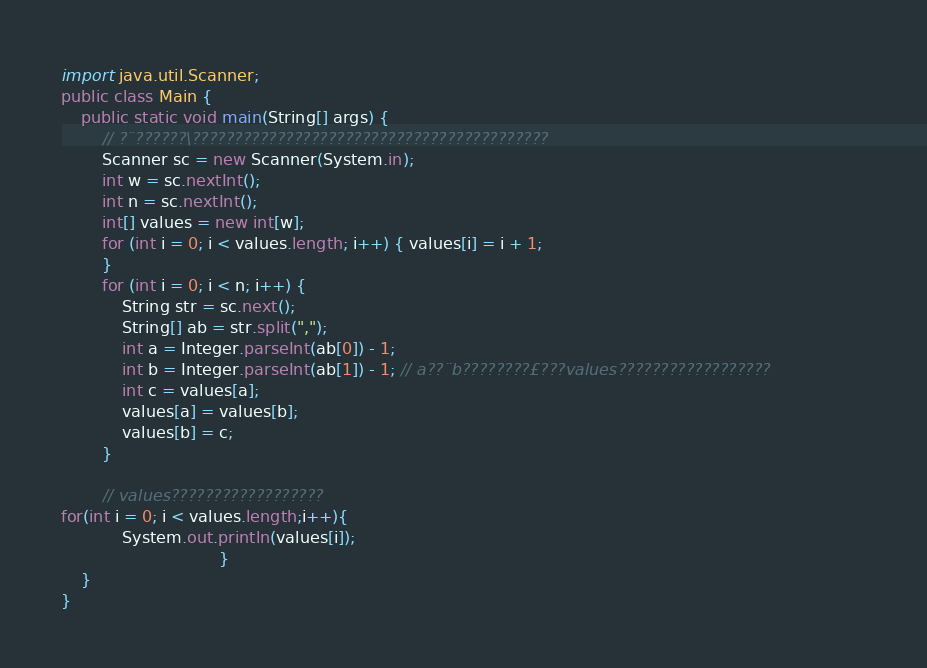Convert code to text. <code><loc_0><loc_0><loc_500><loc_500><_Java_>import java.util.Scanner;
public class Main {
    public static void main(String[] args) {
        // ?¨??????\??????????????????????????????????????????                                                         
        Scanner sc = new Scanner(System.in);
        int w = sc.nextInt();
        int n = sc.nextInt();
        int[] values = new int[w];
        for (int i = 0; i < values.length; i++) { values[i] = i + 1;
        }
        for (int i = 0; i < n; i++) {
            String str = sc.next();
            String[] ab = str.split(",");
            int a = Integer.parseInt(ab[0]) - 1;
            int b = Integer.parseInt(ab[1]) - 1; // a??¨b????????£???values??????????????????                   
            int c = values[a];
            values[a] = values[b];
            values[b] = c;
        }

        // values??????????????????                                                                        
for(int i = 0; i < values.length;i++){
            System.out.println(values[i]);
                               }
    }
}</code> 